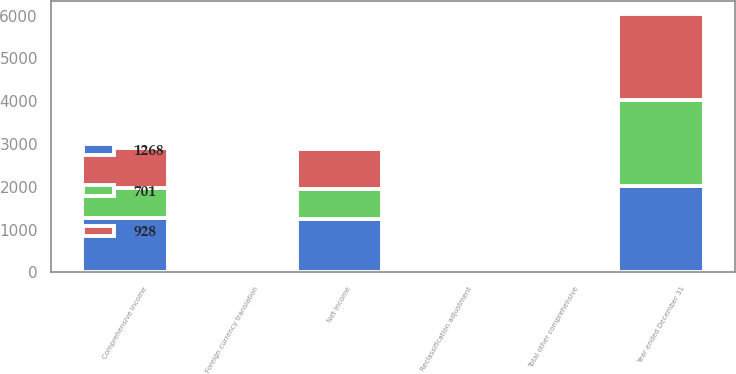Convert chart. <chart><loc_0><loc_0><loc_500><loc_500><stacked_bar_chart><ecel><fcel>Year ended December 31<fcel>Net income<fcel>Reclassification adjustment<fcel>Foreign currency translation<fcel>Total other comprehensive<fcel>Comprehensive income<nl><fcel>1268<fcel>2017<fcel>1246<fcel>6<fcel>12<fcel>22<fcel>1268<nl><fcel>928<fcel>2016<fcel>930<fcel>7<fcel>9<fcel>2<fcel>928<nl><fcel>701<fcel>2015<fcel>712<fcel>10<fcel>21<fcel>11<fcel>701<nl></chart> 